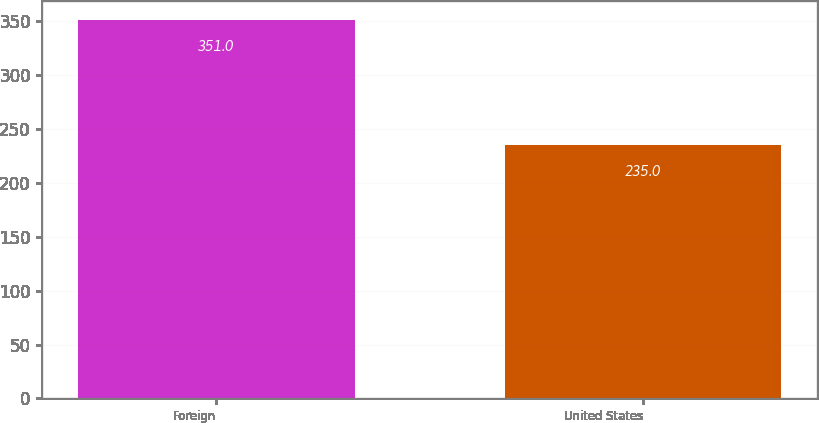Convert chart. <chart><loc_0><loc_0><loc_500><loc_500><bar_chart><fcel>Foreign<fcel>United States<nl><fcel>351<fcel>235<nl></chart> 